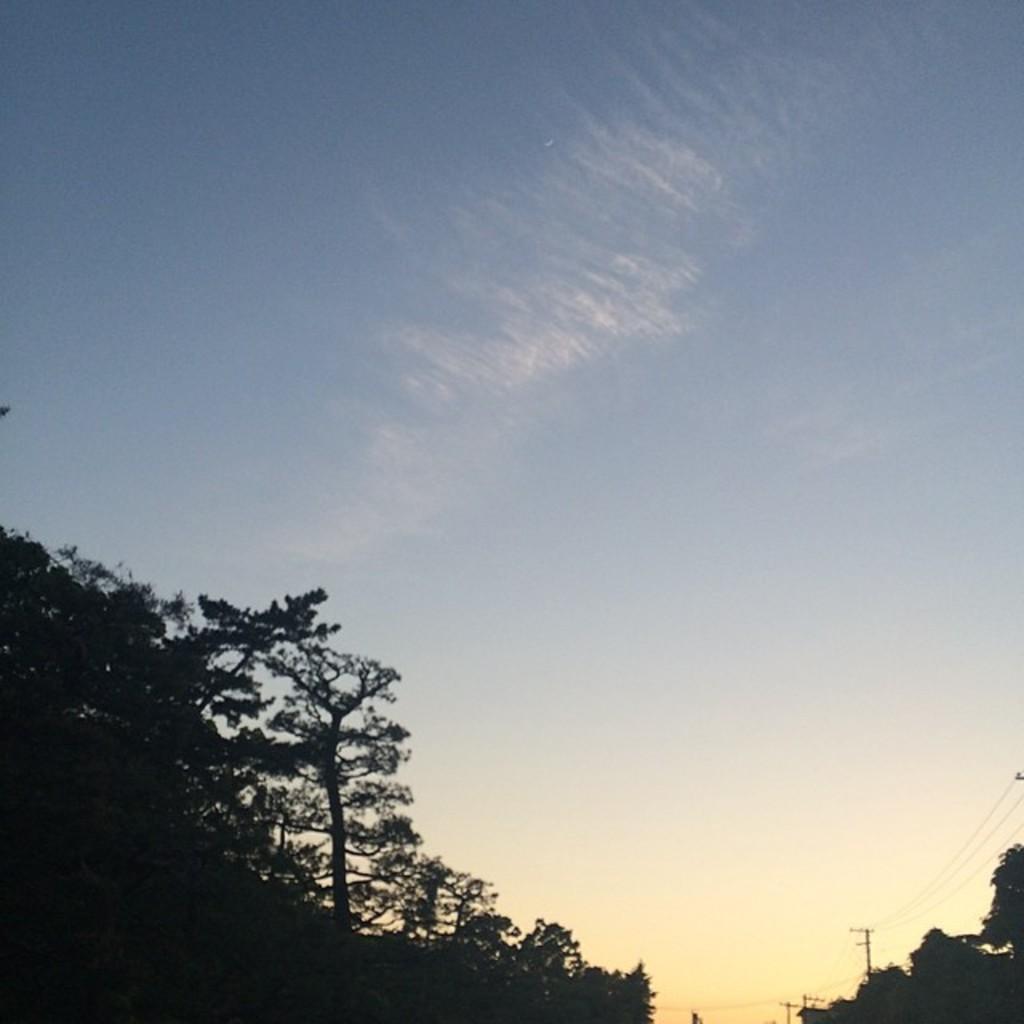Could you give a brief overview of what you see in this image? In this image I can see few trees, poles, wires and the sky is in blue and white color. 